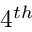Convert formula to latex. <formula><loc_0><loc_0><loc_500><loc_500>4 ^ { t h }</formula> 